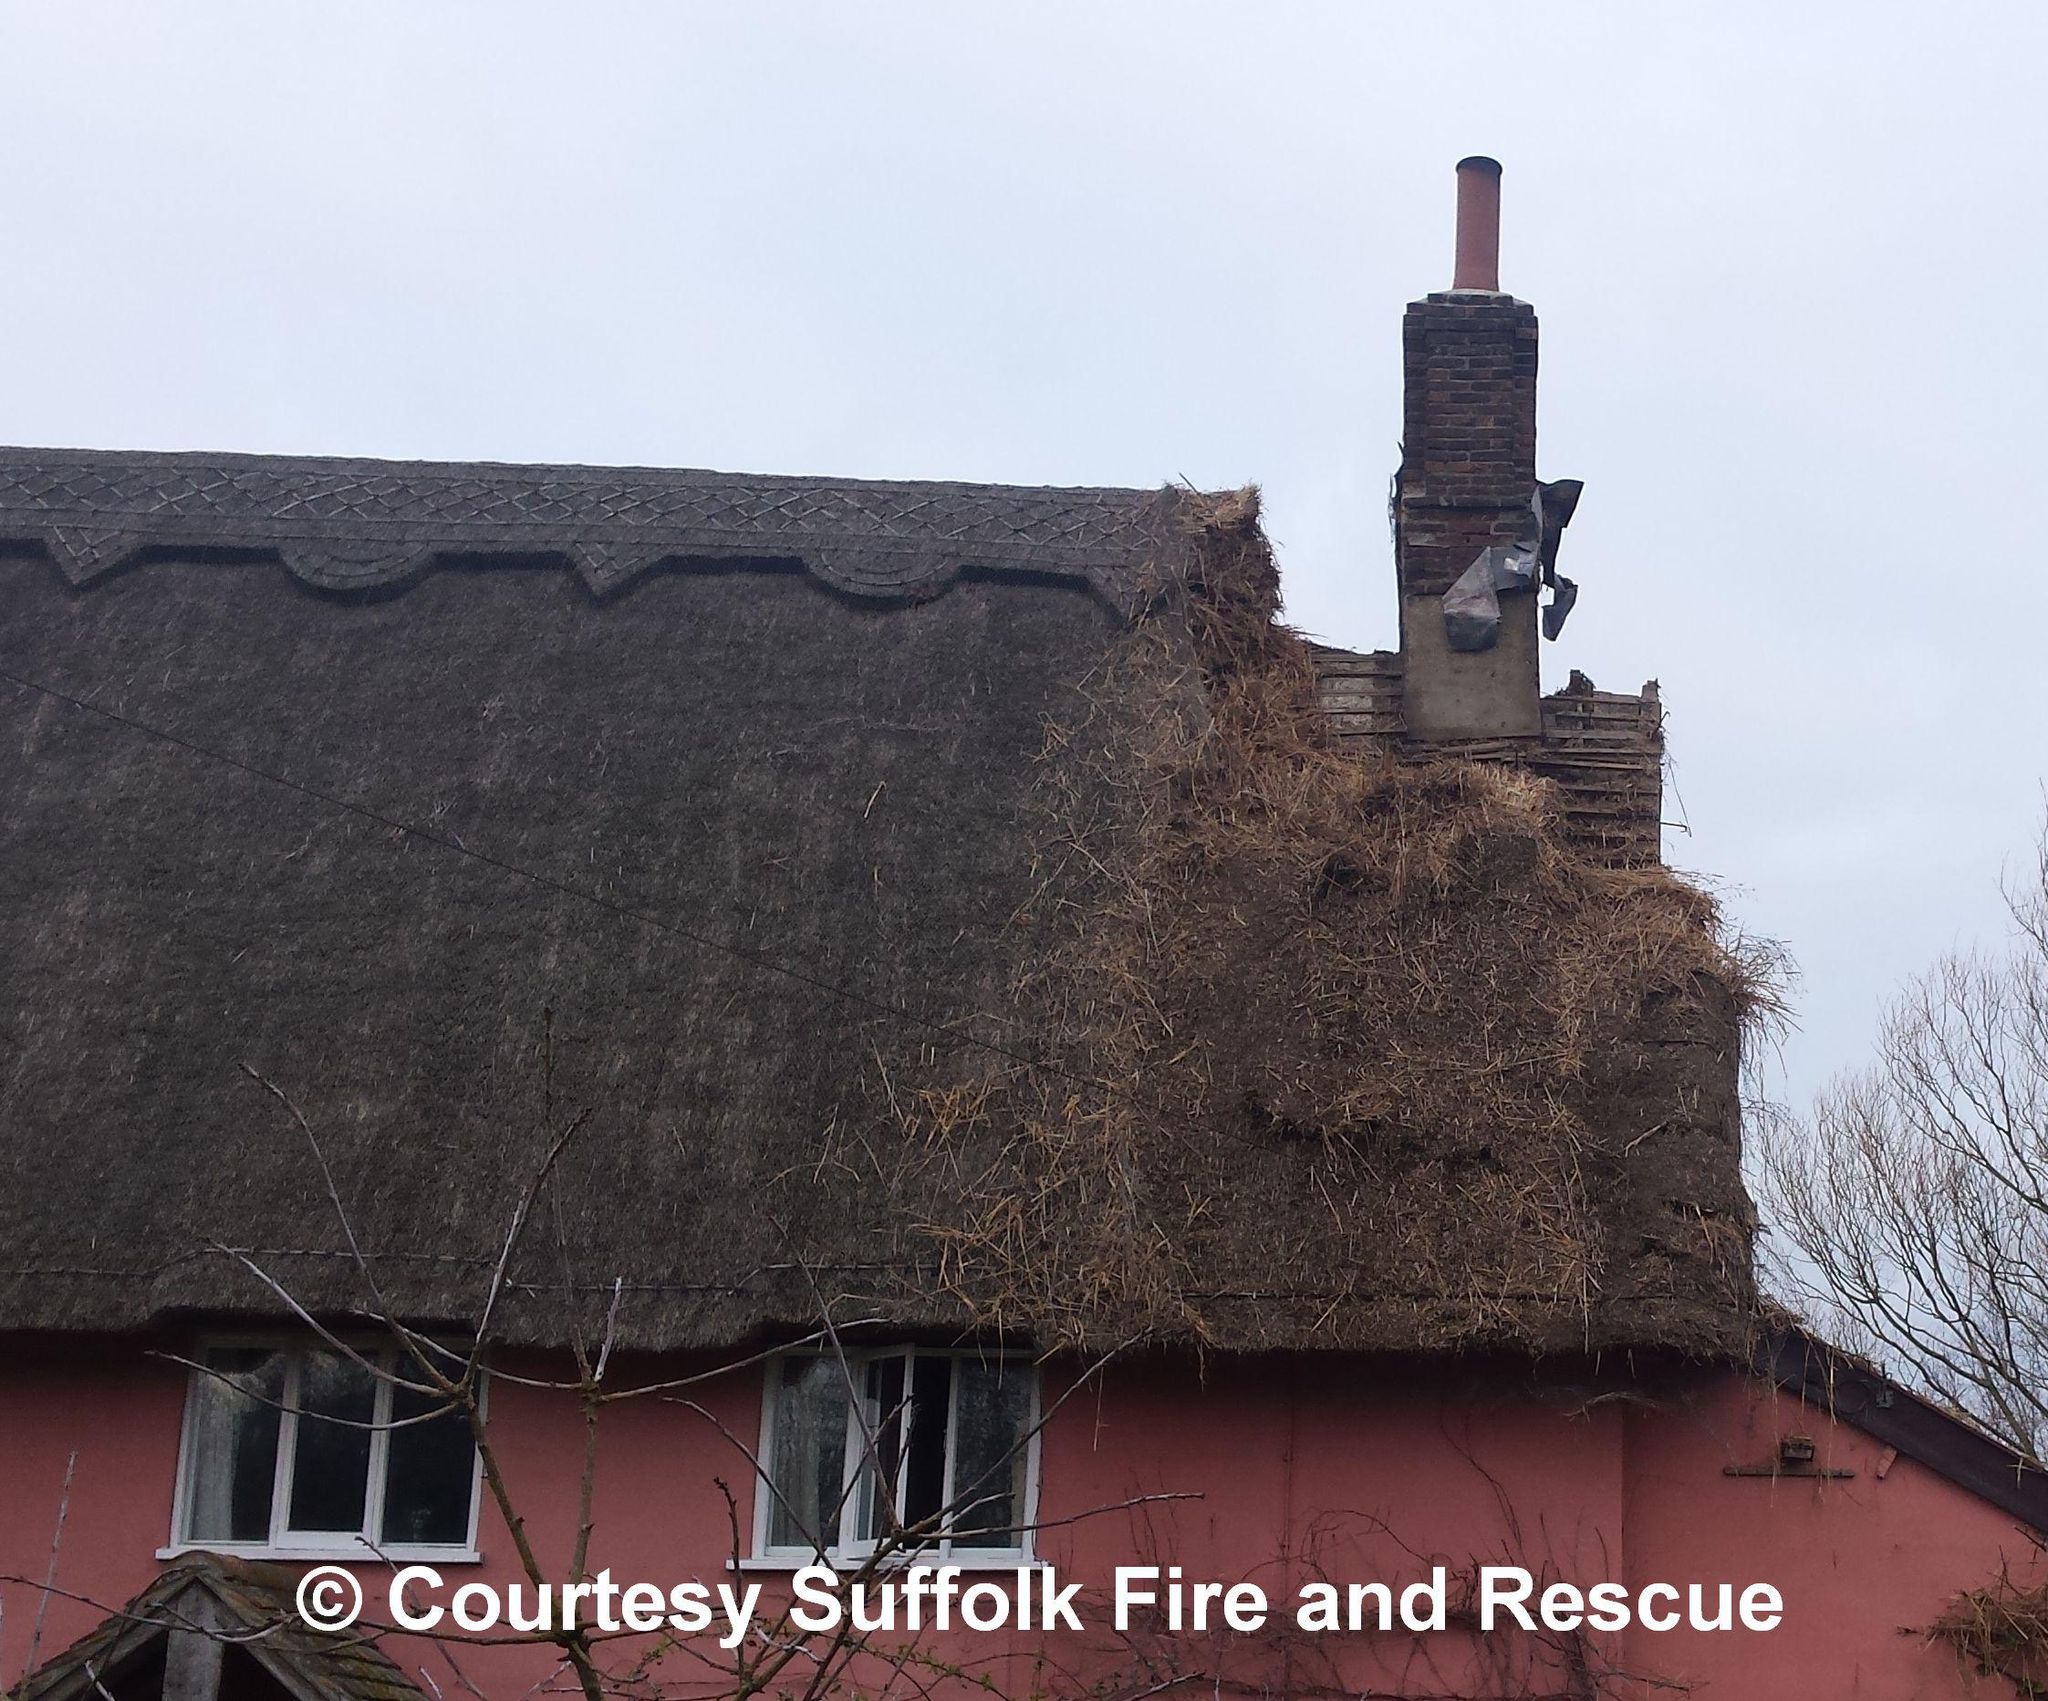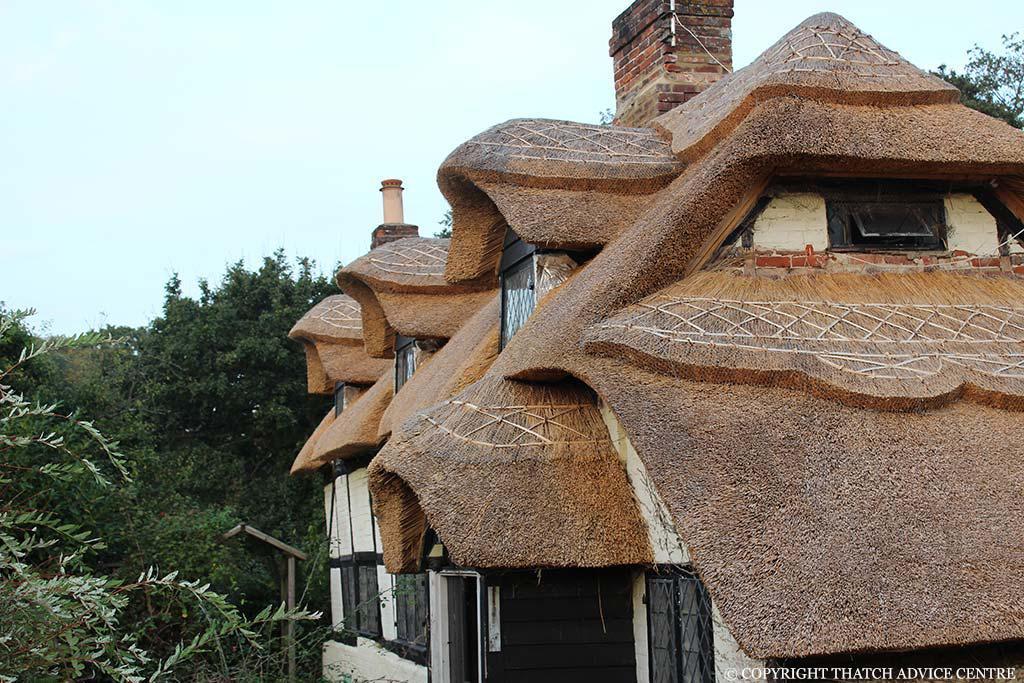The first image is the image on the left, the second image is the image on the right. Given the left and right images, does the statement "The left image shows a ladder leaning against a thatched roof, with the top of the ladder near a red brick chimney." hold true? Answer yes or no. No. The first image is the image on the left, the second image is the image on the right. Considering the images on both sides, is "In at least one image there is a silver ladder placed on the roof pointed toward the brick chimney." valid? Answer yes or no. No. 